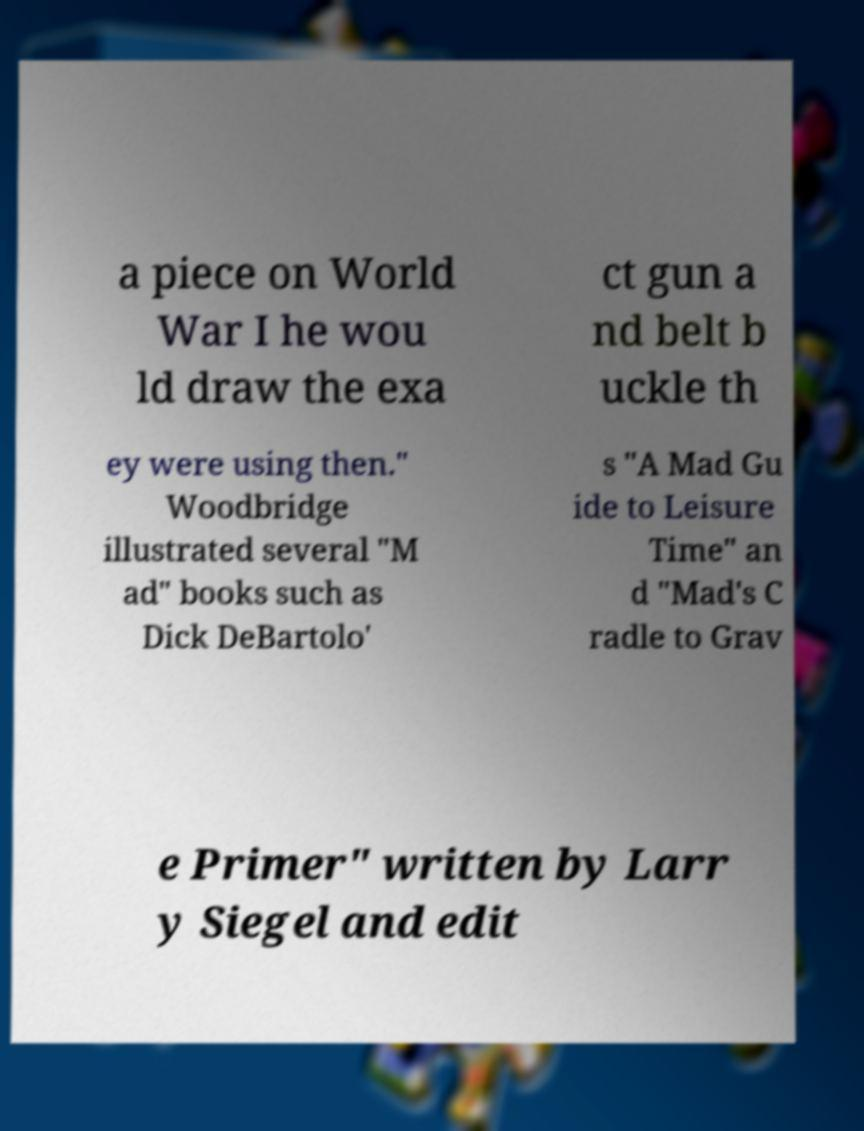Please read and relay the text visible in this image. What does it say? a piece on World War I he wou ld draw the exa ct gun a nd belt b uckle th ey were using then." Woodbridge illustrated several "M ad" books such as Dick DeBartolo' s "A Mad Gu ide to Leisure Time" an d "Mad's C radle to Grav e Primer" written by Larr y Siegel and edit 